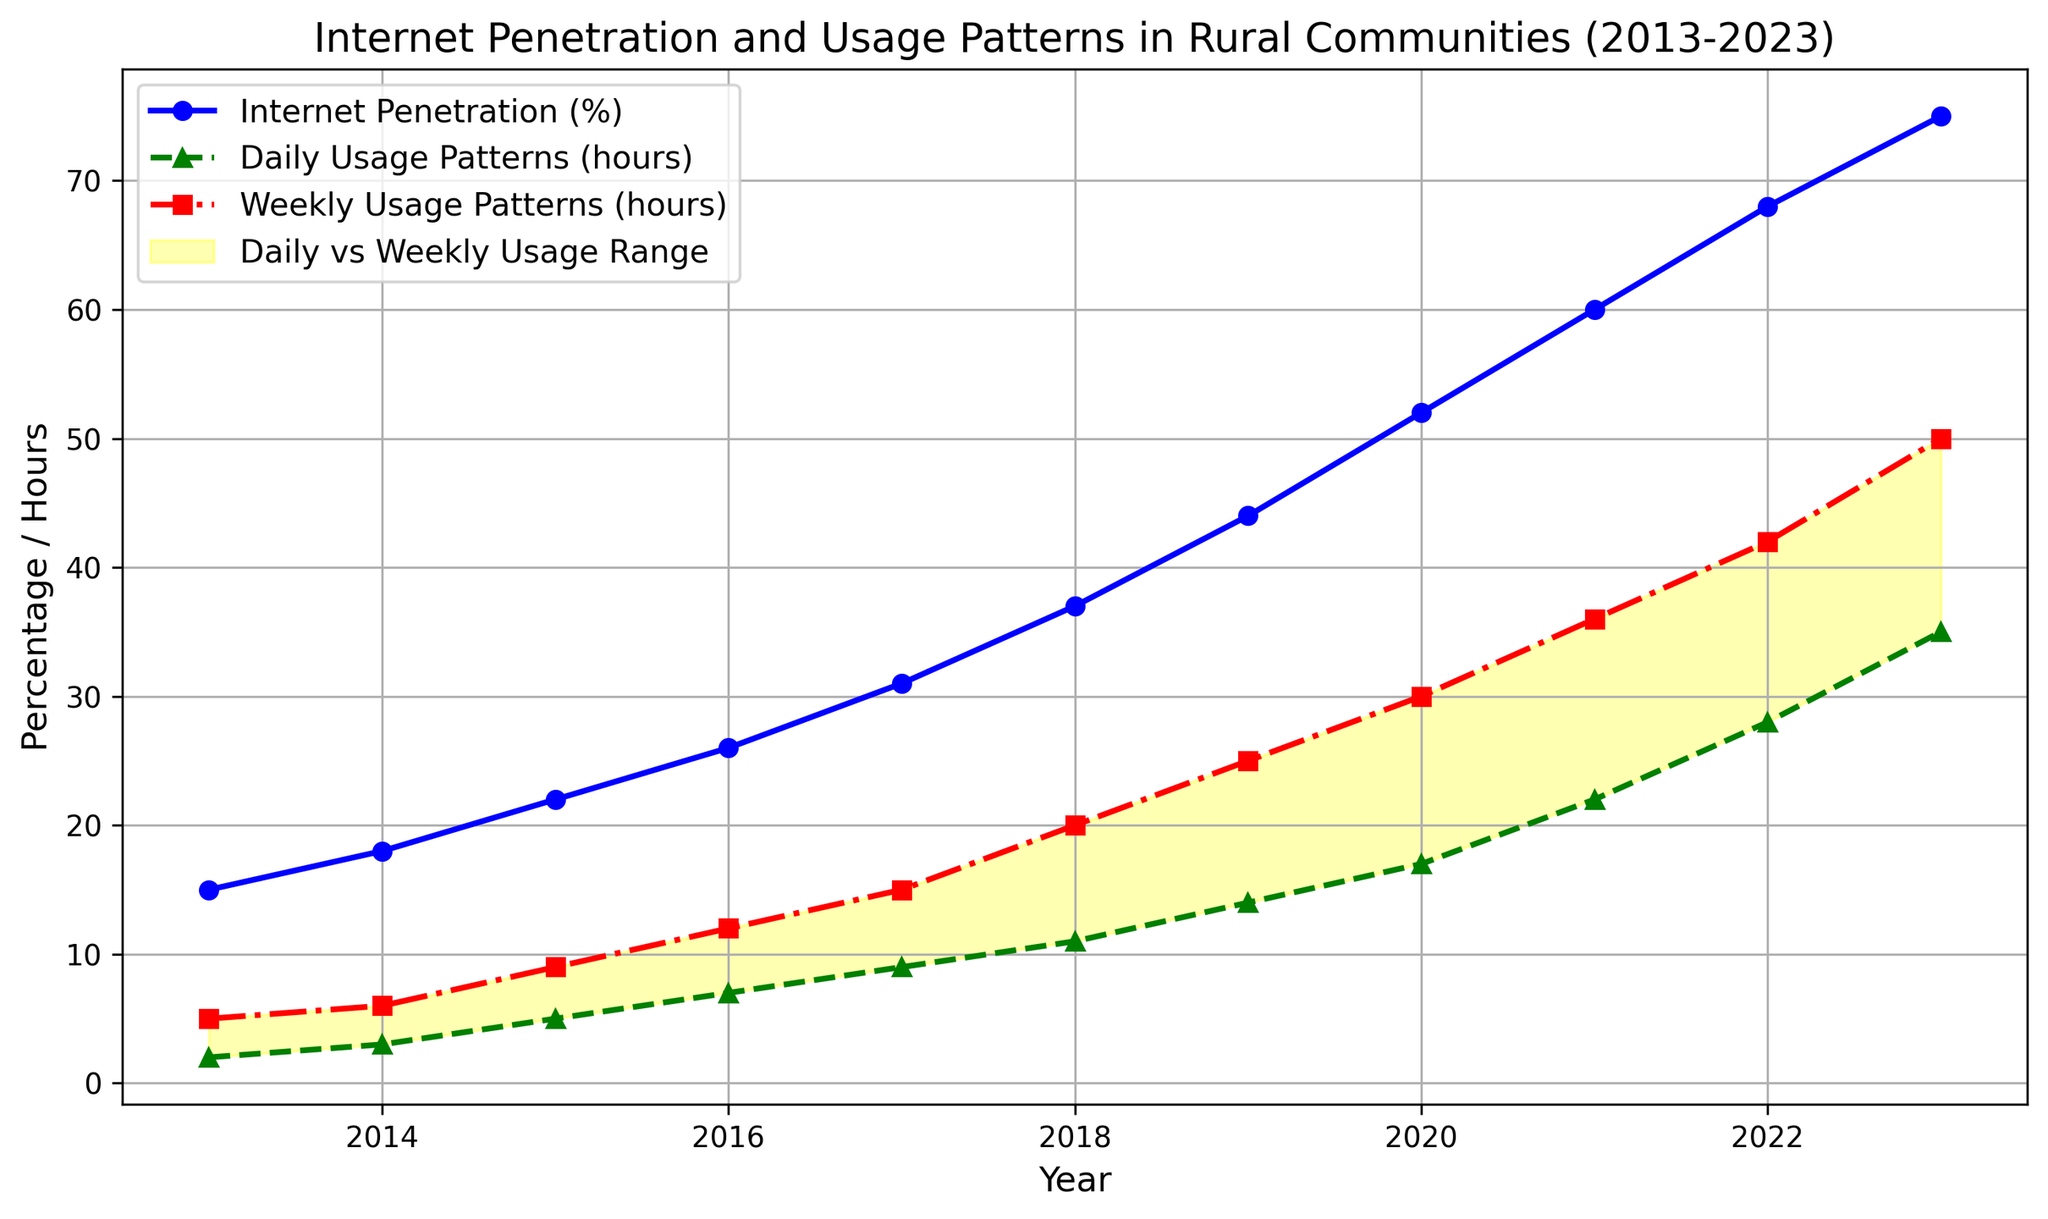At what year did Internet penetration exceed 30%? To answer this, locate the blue line representing Internet penetration and identify the year when the line first crosses the 30% mark. This occurs between 2016 and 2017.
Answer: 2017 What is the difference between daily and weekly usage patterns in 2021? Observe the green (daily usage) and red (weekly usage) lines for the year 2021. Daily usage is at 22 hours and weekly usage is at 36 hours. The difference is 36 - 22.
Answer: 14 hours During which year was the increase in Internet penetration the largest? By comparing the annual increases in the blue line representing Internet penetration, the largest change appears between 2019 and 2020, where the penetration increases from 44% to 52%.
Answer: 2020 What are the overall trends in daily and weekly usage patterns over the decade? Both usage patterns increase over time. The green line (daily usage) and red line (weekly usage) show an upward trend, indicating growing Internet usage in rural communities.
Answer: Increasing trend When did weekly usage patterns first reach 20 hours? Focus on the red line representing weekly usage. The line crosses the 20-hour mark between 2017 and 2018.
Answer: 2018 How much did daily usage increase from 2016 to 2019? Note the green line values for daily usage in 2016 (7 hours) and 2019 (14 hours). The increase is 14 - 7.
Answer: 7 hours Is the gap between daily and weekly usage patterns widening or narrowing over the years? By observing the shaded yellow area between the green and red lines, it becomes clear that the gap (width) is widening as both lines diverge increasingly over the years.
Answer: Widening What is the average Internet penetration from 2013 to 2023? Sum the Internet penetration values from 2013 to 2023 and divide by the total number of years: (15 + 18 + 22 + 26 + 31 + 37 + 44 + 52 + 60 + 68 + 75) / 11. The calculations yield an average.
Answer: 40.73% By how much did Internet penetration increase between 2013 and 2023? To find the increase, subtract the 2013 value (15%) from the 2023 value (75%): 75 - 15.
Answer: 60% Which year saw the smallest increase in weekly usage patterns? By inspecting the red line for yearly increases, the smallest increment appears to be between 2013 and 2014, where it increased from 5 to 6 hours.
Answer: 2014 